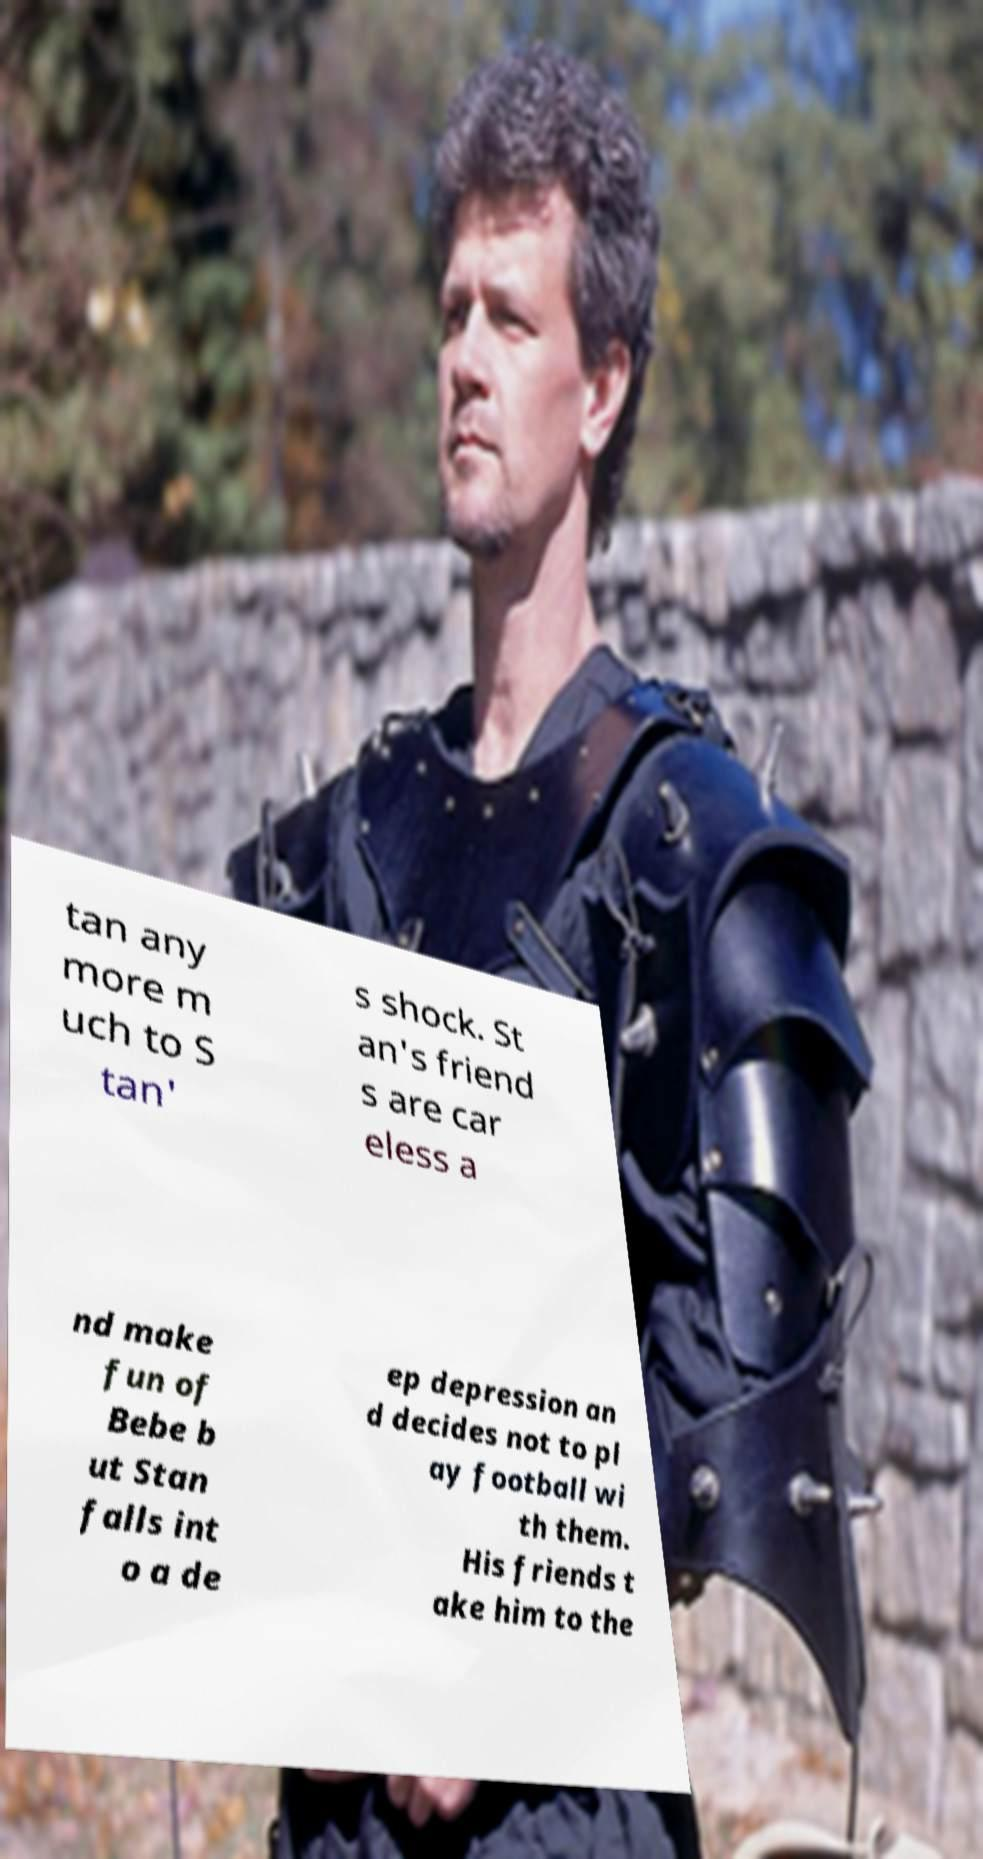I need the written content from this picture converted into text. Can you do that? tan any more m uch to S tan' s shock. St an's friend s are car eless a nd make fun of Bebe b ut Stan falls int o a de ep depression an d decides not to pl ay football wi th them. His friends t ake him to the 